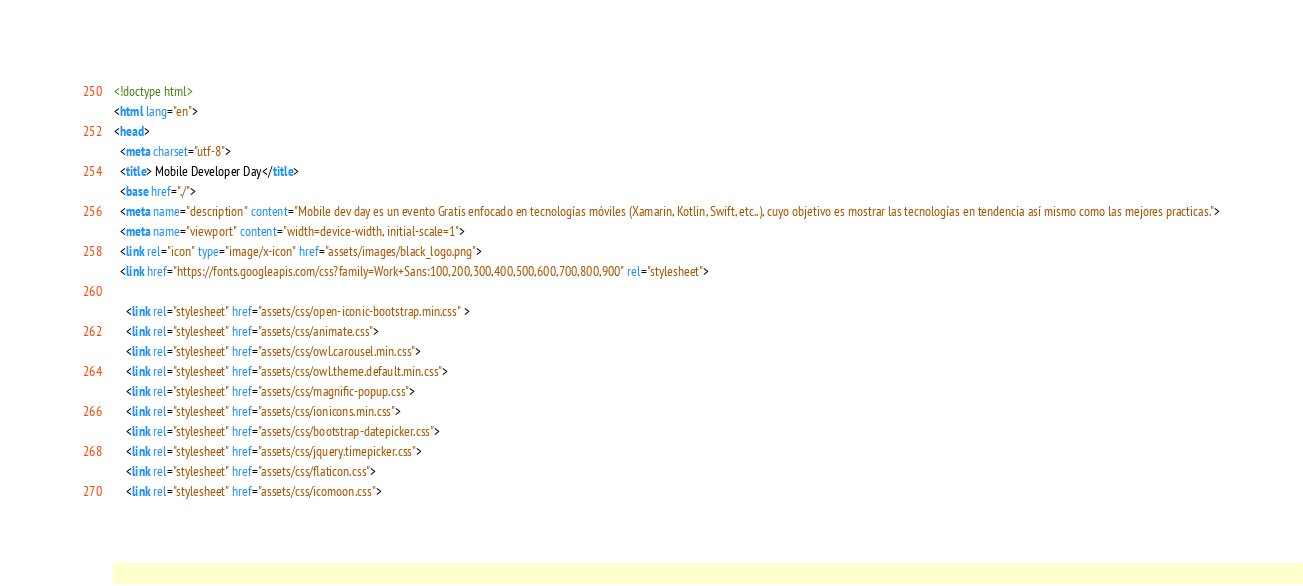<code> <loc_0><loc_0><loc_500><loc_500><_HTML_><!doctype html>
<html lang="en">
<head>
  <meta charset="utf-8">
  <title> Mobile Developer Day</title>
  <base href="./">
  <meta name="description" content="Mobile dev day es un evento Gratis enfocado en tecnologías móviles (Xamarin, Kotlin, Swift, etc..), cuyo objetivo es mostrar las tecnologías en tendencia así mismo como las mejores practicas.">
  <meta name="viewport" content="width=device-width, initial-scale=1">
  <link rel="icon" type="image/x-icon" href="assets/images/black_logo.png">
  <link href="https://fonts.googleapis.com/css?family=Work+Sans:100,200,300,400,500,600,700,800,900" rel="stylesheet">

    <link rel="stylesheet" href="assets/css/open-iconic-bootstrap.min.css" >
    <link rel="stylesheet" href="assets/css/animate.css">
    <link rel="stylesheet" href="assets/css/owl.carousel.min.css">
    <link rel="stylesheet" href="assets/css/owl.theme.default.min.css">
    <link rel="stylesheet" href="assets/css/magnific-popup.css">
    <link rel="stylesheet" href="assets/css/ionicons.min.css">
    <link rel="stylesheet" href="assets/css/bootstrap-datepicker.css">
    <link rel="stylesheet" href="assets/css/jquery.timepicker.css">
    <link rel="stylesheet" href="assets/css/flaticon.css">
    <link rel="stylesheet" href="assets/css/icomoon.css"></code> 